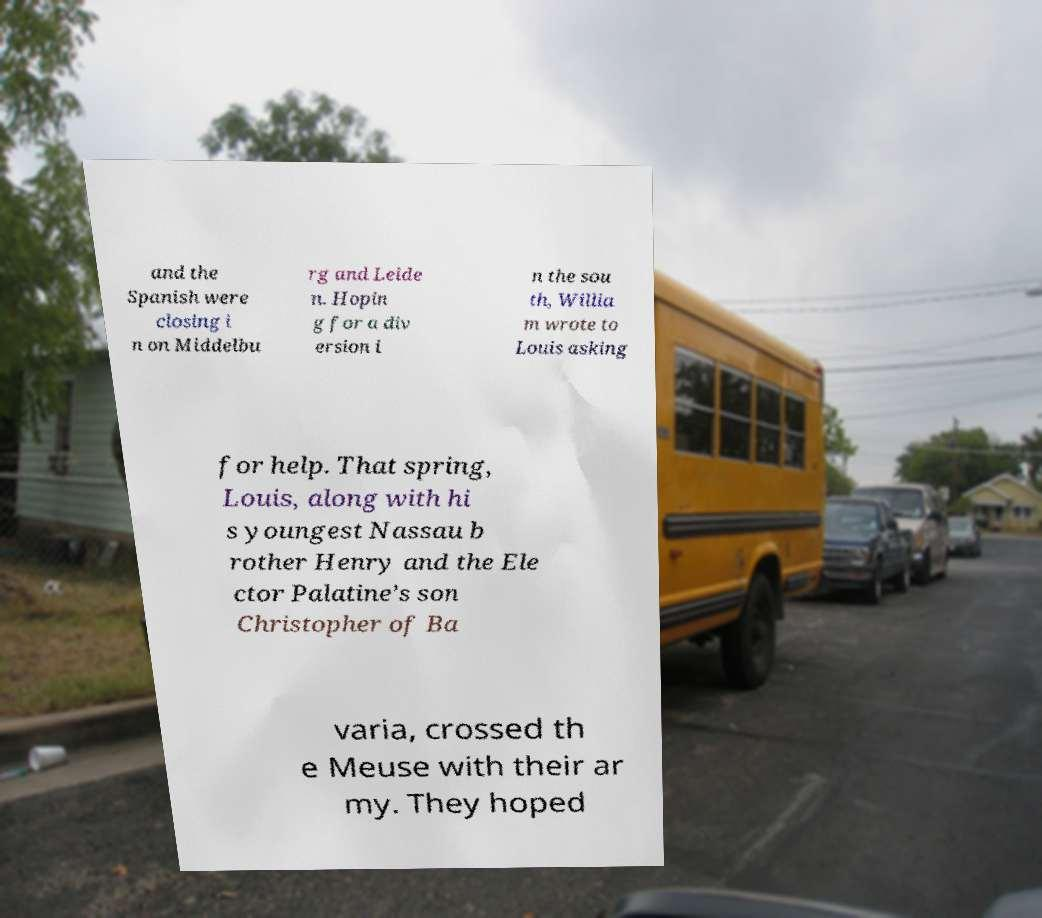What messages or text are displayed in this image? I need them in a readable, typed format. and the Spanish were closing i n on Middelbu rg and Leide n. Hopin g for a div ersion i n the sou th, Willia m wrote to Louis asking for help. That spring, Louis, along with hi s youngest Nassau b rother Henry and the Ele ctor Palatine’s son Christopher of Ba varia, crossed th e Meuse with their ar my. They hoped 